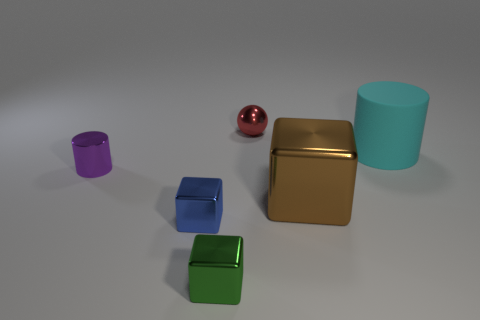Add 2 large cyan matte cylinders. How many objects exist? 8 Subtract all spheres. How many objects are left? 5 Add 4 green cubes. How many green cubes are left? 5 Add 4 tiny metal objects. How many tiny metal objects exist? 8 Subtract 0 blue cylinders. How many objects are left? 6 Subtract all large cyan cylinders. Subtract all cyan cylinders. How many objects are left? 4 